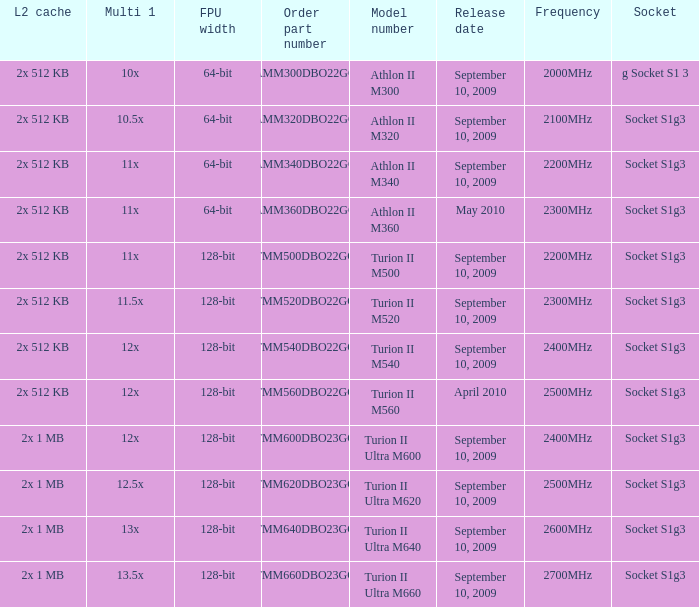What is the frequency of the tmm500dbo22gq order part number? 2200MHz. 